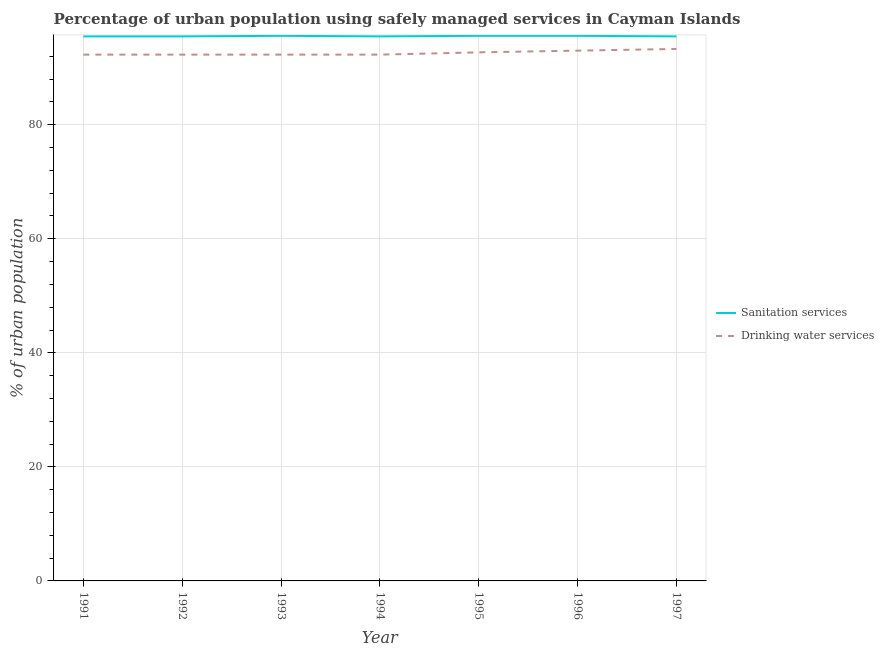Does the line corresponding to percentage of urban population who used sanitation services intersect with the line corresponding to percentage of urban population who used drinking water services?
Offer a terse response. No. Is the number of lines equal to the number of legend labels?
Provide a succinct answer. Yes. What is the percentage of urban population who used drinking water services in 1995?
Provide a succinct answer. 92.7. Across all years, what is the maximum percentage of urban population who used drinking water services?
Provide a short and direct response. 93.3. Across all years, what is the minimum percentage of urban population who used drinking water services?
Your answer should be very brief. 92.3. In which year was the percentage of urban population who used sanitation services maximum?
Your response must be concise. 1993. What is the total percentage of urban population who used drinking water services in the graph?
Provide a succinct answer. 648.2. What is the difference between the percentage of urban population who used sanitation services in 1994 and that in 1995?
Your answer should be compact. -0.1. What is the difference between the percentage of urban population who used sanitation services in 1993 and the percentage of urban population who used drinking water services in 1997?
Ensure brevity in your answer.  2.3. What is the average percentage of urban population who used sanitation services per year?
Make the answer very short. 95.54. In the year 1996, what is the difference between the percentage of urban population who used drinking water services and percentage of urban population who used sanitation services?
Your response must be concise. -2.6. What is the ratio of the percentage of urban population who used sanitation services in 1994 to that in 1995?
Make the answer very short. 1. Is the difference between the percentage of urban population who used drinking water services in 1991 and 1997 greater than the difference between the percentage of urban population who used sanitation services in 1991 and 1997?
Ensure brevity in your answer.  No. In how many years, is the percentage of urban population who used drinking water services greater than the average percentage of urban population who used drinking water services taken over all years?
Offer a very short reply. 3. Is the sum of the percentage of urban population who used drinking water services in 1995 and 1997 greater than the maximum percentage of urban population who used sanitation services across all years?
Keep it short and to the point. Yes. Does the percentage of urban population who used sanitation services monotonically increase over the years?
Keep it short and to the point. No. Is the percentage of urban population who used drinking water services strictly greater than the percentage of urban population who used sanitation services over the years?
Your response must be concise. No. Is the percentage of urban population who used drinking water services strictly less than the percentage of urban population who used sanitation services over the years?
Provide a succinct answer. Yes. How many lines are there?
Your response must be concise. 2. How many years are there in the graph?
Provide a short and direct response. 7. What is the difference between two consecutive major ticks on the Y-axis?
Provide a succinct answer. 20. Does the graph contain any zero values?
Ensure brevity in your answer.  No. How many legend labels are there?
Give a very brief answer. 2. What is the title of the graph?
Your answer should be compact. Percentage of urban population using safely managed services in Cayman Islands. Does "Boys" appear as one of the legend labels in the graph?
Offer a very short reply. No. What is the label or title of the X-axis?
Make the answer very short. Year. What is the label or title of the Y-axis?
Your answer should be compact. % of urban population. What is the % of urban population in Sanitation services in 1991?
Offer a very short reply. 95.5. What is the % of urban population in Drinking water services in 1991?
Give a very brief answer. 92.3. What is the % of urban population of Sanitation services in 1992?
Offer a terse response. 95.5. What is the % of urban population of Drinking water services in 1992?
Keep it short and to the point. 92.3. What is the % of urban population of Sanitation services in 1993?
Make the answer very short. 95.6. What is the % of urban population of Drinking water services in 1993?
Offer a very short reply. 92.3. What is the % of urban population of Sanitation services in 1994?
Offer a terse response. 95.5. What is the % of urban population in Drinking water services in 1994?
Provide a succinct answer. 92.3. What is the % of urban population of Sanitation services in 1995?
Ensure brevity in your answer.  95.6. What is the % of urban population in Drinking water services in 1995?
Your response must be concise. 92.7. What is the % of urban population of Sanitation services in 1996?
Your answer should be compact. 95.6. What is the % of urban population in Drinking water services in 1996?
Provide a short and direct response. 93. What is the % of urban population in Sanitation services in 1997?
Your answer should be compact. 95.5. What is the % of urban population of Drinking water services in 1997?
Provide a succinct answer. 93.3. Across all years, what is the maximum % of urban population in Sanitation services?
Make the answer very short. 95.6. Across all years, what is the maximum % of urban population in Drinking water services?
Your response must be concise. 93.3. Across all years, what is the minimum % of urban population of Sanitation services?
Your response must be concise. 95.5. Across all years, what is the minimum % of urban population of Drinking water services?
Your answer should be very brief. 92.3. What is the total % of urban population of Sanitation services in the graph?
Your answer should be compact. 668.8. What is the total % of urban population of Drinking water services in the graph?
Keep it short and to the point. 648.2. What is the difference between the % of urban population of Sanitation services in 1991 and that in 1992?
Your answer should be very brief. 0. What is the difference between the % of urban population in Drinking water services in 1991 and that in 1992?
Your response must be concise. 0. What is the difference between the % of urban population in Sanitation services in 1991 and that in 1994?
Offer a terse response. 0. What is the difference between the % of urban population of Drinking water services in 1991 and that in 1994?
Offer a very short reply. 0. What is the difference between the % of urban population of Sanitation services in 1991 and that in 1995?
Make the answer very short. -0.1. What is the difference between the % of urban population of Sanitation services in 1991 and that in 1997?
Your answer should be very brief. 0. What is the difference between the % of urban population in Sanitation services in 1992 and that in 1994?
Provide a short and direct response. 0. What is the difference between the % of urban population of Drinking water services in 1992 and that in 1995?
Offer a very short reply. -0.4. What is the difference between the % of urban population of Sanitation services in 1992 and that in 1996?
Offer a terse response. -0.1. What is the difference between the % of urban population of Drinking water services in 1992 and that in 1996?
Your response must be concise. -0.7. What is the difference between the % of urban population in Sanitation services in 1992 and that in 1997?
Provide a short and direct response. 0. What is the difference between the % of urban population in Drinking water services in 1992 and that in 1997?
Provide a succinct answer. -1. What is the difference between the % of urban population of Sanitation services in 1993 and that in 1996?
Provide a short and direct response. 0. What is the difference between the % of urban population in Sanitation services in 1993 and that in 1997?
Your answer should be very brief. 0.1. What is the difference between the % of urban population of Sanitation services in 1994 and that in 1995?
Give a very brief answer. -0.1. What is the difference between the % of urban population in Drinking water services in 1994 and that in 1996?
Offer a very short reply. -0.7. What is the difference between the % of urban population of Sanitation services in 1994 and that in 1997?
Your response must be concise. 0. What is the difference between the % of urban population in Sanitation services in 1995 and that in 1996?
Provide a succinct answer. 0. What is the difference between the % of urban population of Sanitation services in 1995 and that in 1997?
Provide a short and direct response. 0.1. What is the difference between the % of urban population of Drinking water services in 1996 and that in 1997?
Offer a very short reply. -0.3. What is the difference between the % of urban population of Sanitation services in 1991 and the % of urban population of Drinking water services in 1993?
Your response must be concise. 3.2. What is the difference between the % of urban population in Sanitation services in 1991 and the % of urban population in Drinking water services in 1996?
Your response must be concise. 2.5. What is the difference between the % of urban population in Sanitation services in 1992 and the % of urban population in Drinking water services in 1993?
Offer a very short reply. 3.2. What is the difference between the % of urban population in Sanitation services in 1992 and the % of urban population in Drinking water services in 1994?
Ensure brevity in your answer.  3.2. What is the difference between the % of urban population in Sanitation services in 1992 and the % of urban population in Drinking water services in 1995?
Offer a terse response. 2.8. What is the difference between the % of urban population in Sanitation services in 1992 and the % of urban population in Drinking water services in 1996?
Ensure brevity in your answer.  2.5. What is the difference between the % of urban population of Sanitation services in 1992 and the % of urban population of Drinking water services in 1997?
Keep it short and to the point. 2.2. What is the difference between the % of urban population of Sanitation services in 1993 and the % of urban population of Drinking water services in 1997?
Your answer should be compact. 2.3. What is the difference between the % of urban population of Sanitation services in 1994 and the % of urban population of Drinking water services in 1995?
Your answer should be very brief. 2.8. What is the difference between the % of urban population of Sanitation services in 1994 and the % of urban population of Drinking water services in 1996?
Give a very brief answer. 2.5. What is the difference between the % of urban population of Sanitation services in 1995 and the % of urban population of Drinking water services in 1996?
Offer a very short reply. 2.6. What is the average % of urban population of Sanitation services per year?
Keep it short and to the point. 95.54. What is the average % of urban population of Drinking water services per year?
Keep it short and to the point. 92.6. In the year 1992, what is the difference between the % of urban population in Sanitation services and % of urban population in Drinking water services?
Offer a terse response. 3.2. In the year 1995, what is the difference between the % of urban population in Sanitation services and % of urban population in Drinking water services?
Your response must be concise. 2.9. In the year 1996, what is the difference between the % of urban population of Sanitation services and % of urban population of Drinking water services?
Offer a terse response. 2.6. What is the ratio of the % of urban population in Sanitation services in 1991 to that in 1993?
Make the answer very short. 1. What is the ratio of the % of urban population of Drinking water services in 1991 to that in 1994?
Offer a terse response. 1. What is the ratio of the % of urban population in Sanitation services in 1991 to that in 1995?
Make the answer very short. 1. What is the ratio of the % of urban population in Drinking water services in 1991 to that in 1996?
Make the answer very short. 0.99. What is the ratio of the % of urban population of Sanitation services in 1991 to that in 1997?
Make the answer very short. 1. What is the ratio of the % of urban population in Drinking water services in 1991 to that in 1997?
Your answer should be compact. 0.99. What is the ratio of the % of urban population in Sanitation services in 1992 to that in 1993?
Your response must be concise. 1. What is the ratio of the % of urban population in Drinking water services in 1992 to that in 1993?
Your answer should be very brief. 1. What is the ratio of the % of urban population in Drinking water services in 1992 to that in 1994?
Make the answer very short. 1. What is the ratio of the % of urban population of Sanitation services in 1992 to that in 1996?
Your answer should be compact. 1. What is the ratio of the % of urban population in Drinking water services in 1992 to that in 1996?
Offer a terse response. 0.99. What is the ratio of the % of urban population of Sanitation services in 1992 to that in 1997?
Give a very brief answer. 1. What is the ratio of the % of urban population in Drinking water services in 1992 to that in 1997?
Your answer should be compact. 0.99. What is the ratio of the % of urban population of Sanitation services in 1993 to that in 1994?
Make the answer very short. 1. What is the ratio of the % of urban population in Drinking water services in 1993 to that in 1994?
Give a very brief answer. 1. What is the ratio of the % of urban population in Drinking water services in 1993 to that in 1996?
Offer a very short reply. 0.99. What is the ratio of the % of urban population in Drinking water services in 1993 to that in 1997?
Offer a very short reply. 0.99. What is the ratio of the % of urban population of Sanitation services in 1994 to that in 1996?
Provide a succinct answer. 1. What is the ratio of the % of urban population of Drinking water services in 1994 to that in 1997?
Make the answer very short. 0.99. What is the ratio of the % of urban population of Sanitation services in 1995 to that in 1996?
Give a very brief answer. 1. What is the ratio of the % of urban population of Sanitation services in 1995 to that in 1997?
Keep it short and to the point. 1. What is the ratio of the % of urban population in Drinking water services in 1995 to that in 1997?
Keep it short and to the point. 0.99. What is the ratio of the % of urban population in Sanitation services in 1996 to that in 1997?
Your response must be concise. 1. What is the difference between the highest and the second highest % of urban population of Drinking water services?
Your response must be concise. 0.3. 